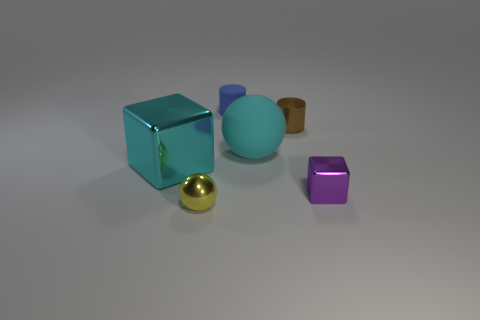There is a metallic block that is in front of the large cyan cube; is its size the same as the object that is in front of the purple metal object?
Your answer should be compact. Yes. What number of balls are either tiny blue rubber objects or large cyan shiny objects?
Ensure brevity in your answer.  0. Is the large cyan thing that is on the right side of the blue cylinder made of the same material as the tiny brown cylinder?
Make the answer very short. No. What number of other objects are the same size as the yellow shiny sphere?
Your answer should be compact. 3. How many large things are gray metal things or purple blocks?
Keep it short and to the point. 0. Is the color of the shiny ball the same as the metallic cylinder?
Ensure brevity in your answer.  No. Is the number of yellow shiny balls behind the tiny blue rubber cylinder greater than the number of cyan metal cubes that are in front of the tiny block?
Ensure brevity in your answer.  No. There is a large thing that is to the left of the small ball; does it have the same color as the small shiny ball?
Keep it short and to the point. No. Is there anything else that has the same color as the large matte thing?
Your response must be concise. Yes. Is the number of yellow metallic things behind the tiny brown metallic cylinder greater than the number of small blue matte objects?
Make the answer very short. No. 